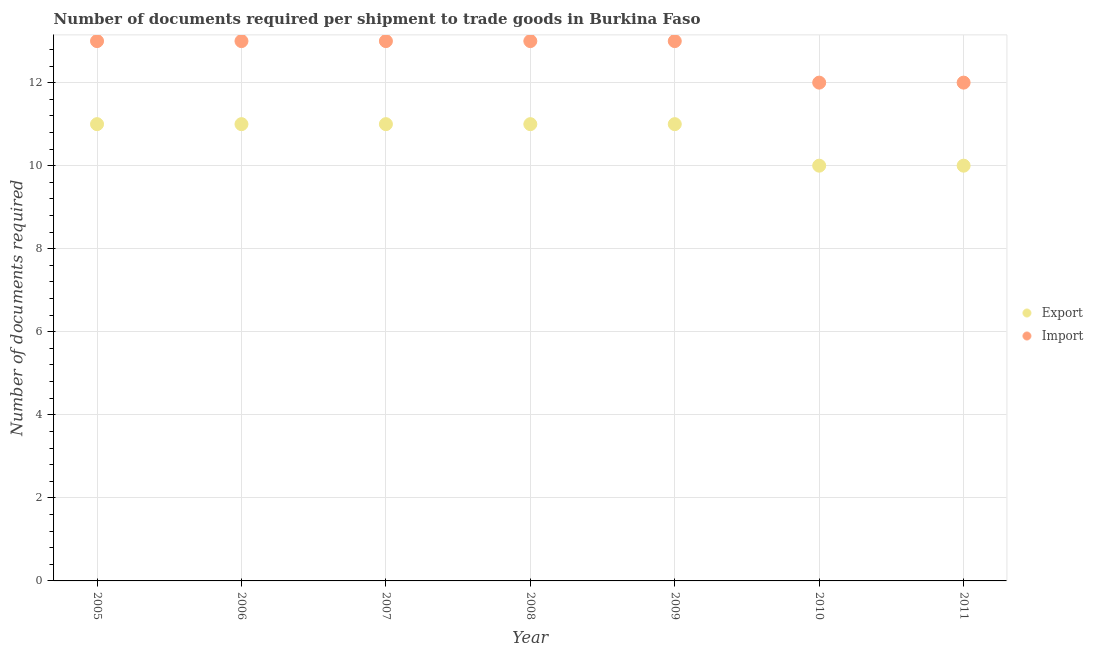What is the number of documents required to export goods in 2009?
Ensure brevity in your answer.  11. Across all years, what is the maximum number of documents required to import goods?
Provide a succinct answer. 13. Across all years, what is the minimum number of documents required to import goods?
Offer a terse response. 12. What is the total number of documents required to export goods in the graph?
Give a very brief answer. 75. What is the difference between the number of documents required to export goods in 2005 and that in 2006?
Your answer should be very brief. 0. What is the difference between the number of documents required to import goods in 2011 and the number of documents required to export goods in 2010?
Your response must be concise. 2. What is the average number of documents required to import goods per year?
Give a very brief answer. 12.71. In the year 2008, what is the difference between the number of documents required to export goods and number of documents required to import goods?
Keep it short and to the point. -2. What is the ratio of the number of documents required to import goods in 2005 to that in 2006?
Keep it short and to the point. 1. Is the difference between the number of documents required to export goods in 2007 and 2008 greater than the difference between the number of documents required to import goods in 2007 and 2008?
Make the answer very short. No. What is the difference between the highest and the second highest number of documents required to import goods?
Provide a short and direct response. 0. What is the difference between the highest and the lowest number of documents required to export goods?
Provide a short and direct response. 1. In how many years, is the number of documents required to import goods greater than the average number of documents required to import goods taken over all years?
Keep it short and to the point. 5. Does the number of documents required to import goods monotonically increase over the years?
Provide a short and direct response. No. Is the number of documents required to export goods strictly less than the number of documents required to import goods over the years?
Ensure brevity in your answer.  Yes. How many years are there in the graph?
Provide a succinct answer. 7. Are the values on the major ticks of Y-axis written in scientific E-notation?
Provide a succinct answer. No. Does the graph contain any zero values?
Provide a succinct answer. No. Does the graph contain grids?
Provide a succinct answer. Yes. How many legend labels are there?
Keep it short and to the point. 2. How are the legend labels stacked?
Provide a succinct answer. Vertical. What is the title of the graph?
Make the answer very short. Number of documents required per shipment to trade goods in Burkina Faso. Does "Official aid received" appear as one of the legend labels in the graph?
Your response must be concise. No. What is the label or title of the Y-axis?
Provide a short and direct response. Number of documents required. What is the Number of documents required of Export in 2005?
Provide a short and direct response. 11. What is the Number of documents required in Import in 2005?
Your answer should be very brief. 13. What is the Number of documents required of Export in 2006?
Provide a short and direct response. 11. What is the Number of documents required in Export in 2007?
Keep it short and to the point. 11. What is the Number of documents required in Export in 2011?
Provide a succinct answer. 10. Across all years, what is the minimum Number of documents required in Export?
Your response must be concise. 10. What is the total Number of documents required of Import in the graph?
Offer a very short reply. 89. What is the difference between the Number of documents required in Import in 2005 and that in 2007?
Ensure brevity in your answer.  0. What is the difference between the Number of documents required of Export in 2005 and that in 2008?
Give a very brief answer. 0. What is the difference between the Number of documents required in Import in 2005 and that in 2008?
Ensure brevity in your answer.  0. What is the difference between the Number of documents required of Export in 2005 and that in 2009?
Make the answer very short. 0. What is the difference between the Number of documents required of Import in 2005 and that in 2009?
Provide a succinct answer. 0. What is the difference between the Number of documents required in Import in 2005 and that in 2011?
Ensure brevity in your answer.  1. What is the difference between the Number of documents required of Import in 2006 and that in 2007?
Provide a succinct answer. 0. What is the difference between the Number of documents required in Export in 2006 and that in 2008?
Keep it short and to the point. 0. What is the difference between the Number of documents required in Import in 2006 and that in 2008?
Your response must be concise. 0. What is the difference between the Number of documents required in Import in 2006 and that in 2009?
Make the answer very short. 0. What is the difference between the Number of documents required of Export in 2007 and that in 2011?
Provide a succinct answer. 1. What is the difference between the Number of documents required in Import in 2007 and that in 2011?
Offer a terse response. 1. What is the difference between the Number of documents required in Export in 2008 and that in 2009?
Make the answer very short. 0. What is the difference between the Number of documents required of Export in 2008 and that in 2010?
Provide a short and direct response. 1. What is the difference between the Number of documents required of Export in 2008 and that in 2011?
Keep it short and to the point. 1. What is the difference between the Number of documents required in Import in 2008 and that in 2011?
Offer a very short reply. 1. What is the difference between the Number of documents required in Export in 2009 and that in 2011?
Your response must be concise. 1. What is the difference between the Number of documents required in Import in 2009 and that in 2011?
Provide a succinct answer. 1. What is the difference between the Number of documents required in Import in 2010 and that in 2011?
Your answer should be compact. 0. What is the difference between the Number of documents required of Export in 2005 and the Number of documents required of Import in 2006?
Keep it short and to the point. -2. What is the difference between the Number of documents required in Export in 2005 and the Number of documents required in Import in 2008?
Provide a short and direct response. -2. What is the difference between the Number of documents required of Export in 2006 and the Number of documents required of Import in 2008?
Your answer should be very brief. -2. What is the difference between the Number of documents required in Export in 2006 and the Number of documents required in Import in 2009?
Your answer should be very brief. -2. What is the difference between the Number of documents required in Export in 2006 and the Number of documents required in Import in 2010?
Your answer should be compact. -1. What is the difference between the Number of documents required of Export in 2007 and the Number of documents required of Import in 2010?
Ensure brevity in your answer.  -1. What is the difference between the Number of documents required of Export in 2008 and the Number of documents required of Import in 2011?
Your response must be concise. -1. What is the difference between the Number of documents required of Export in 2009 and the Number of documents required of Import in 2010?
Your answer should be compact. -1. What is the difference between the Number of documents required of Export in 2010 and the Number of documents required of Import in 2011?
Ensure brevity in your answer.  -2. What is the average Number of documents required of Export per year?
Offer a terse response. 10.71. What is the average Number of documents required of Import per year?
Your answer should be compact. 12.71. In the year 2005, what is the difference between the Number of documents required in Export and Number of documents required in Import?
Your answer should be compact. -2. In the year 2008, what is the difference between the Number of documents required in Export and Number of documents required in Import?
Offer a terse response. -2. In the year 2009, what is the difference between the Number of documents required of Export and Number of documents required of Import?
Your answer should be very brief. -2. In the year 2011, what is the difference between the Number of documents required of Export and Number of documents required of Import?
Provide a succinct answer. -2. What is the ratio of the Number of documents required in Export in 2005 to that in 2006?
Make the answer very short. 1. What is the ratio of the Number of documents required of Import in 2005 to that in 2006?
Your response must be concise. 1. What is the ratio of the Number of documents required in Export in 2005 to that in 2007?
Provide a succinct answer. 1. What is the ratio of the Number of documents required in Import in 2005 to that in 2007?
Make the answer very short. 1. What is the ratio of the Number of documents required in Export in 2005 to that in 2009?
Keep it short and to the point. 1. What is the ratio of the Number of documents required of Import in 2006 to that in 2007?
Give a very brief answer. 1. What is the ratio of the Number of documents required of Export in 2006 to that in 2009?
Your answer should be compact. 1. What is the ratio of the Number of documents required of Export in 2006 to that in 2010?
Keep it short and to the point. 1.1. What is the ratio of the Number of documents required in Import in 2006 to that in 2010?
Your answer should be very brief. 1.08. What is the ratio of the Number of documents required of Export in 2006 to that in 2011?
Provide a short and direct response. 1.1. What is the ratio of the Number of documents required of Import in 2006 to that in 2011?
Provide a succinct answer. 1.08. What is the ratio of the Number of documents required in Export in 2007 to that in 2008?
Keep it short and to the point. 1. What is the ratio of the Number of documents required of Export in 2007 to that in 2009?
Your answer should be compact. 1. What is the ratio of the Number of documents required in Export in 2007 to that in 2010?
Your response must be concise. 1.1. What is the ratio of the Number of documents required of Import in 2007 to that in 2010?
Ensure brevity in your answer.  1.08. What is the ratio of the Number of documents required of Export in 2007 to that in 2011?
Offer a terse response. 1.1. What is the ratio of the Number of documents required of Import in 2007 to that in 2011?
Your response must be concise. 1.08. What is the ratio of the Number of documents required in Import in 2008 to that in 2009?
Your answer should be compact. 1. What is the ratio of the Number of documents required in Export in 2008 to that in 2011?
Ensure brevity in your answer.  1.1. What is the ratio of the Number of documents required in Import in 2008 to that in 2011?
Ensure brevity in your answer.  1.08. What is the ratio of the Number of documents required of Export in 2009 to that in 2010?
Your answer should be compact. 1.1. What is the ratio of the Number of documents required of Export in 2009 to that in 2011?
Keep it short and to the point. 1.1. What is the ratio of the Number of documents required in Import in 2009 to that in 2011?
Ensure brevity in your answer.  1.08. What is the difference between the highest and the second highest Number of documents required of Export?
Provide a short and direct response. 0. 